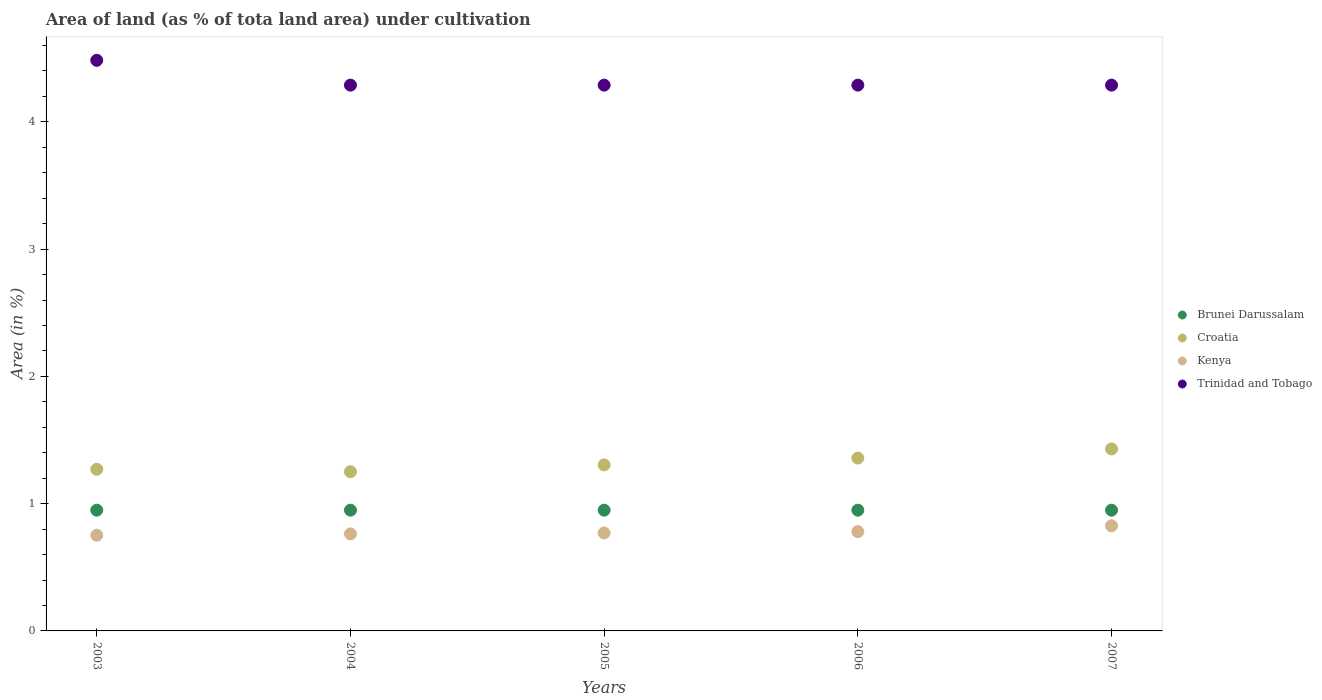How many different coloured dotlines are there?
Make the answer very short. 4. What is the percentage of land under cultivation in Trinidad and Tobago in 2004?
Provide a short and direct response. 4.29. Across all years, what is the maximum percentage of land under cultivation in Brunei Darussalam?
Make the answer very short. 0.95. Across all years, what is the minimum percentage of land under cultivation in Brunei Darussalam?
Your answer should be compact. 0.95. In which year was the percentage of land under cultivation in Kenya minimum?
Give a very brief answer. 2003. What is the total percentage of land under cultivation in Brunei Darussalam in the graph?
Give a very brief answer. 4.74. What is the difference between the percentage of land under cultivation in Trinidad and Tobago in 2005 and that in 2007?
Keep it short and to the point. 0. What is the difference between the percentage of land under cultivation in Trinidad and Tobago in 2004 and the percentage of land under cultivation in Brunei Darussalam in 2003?
Give a very brief answer. 3.34. What is the average percentage of land under cultivation in Croatia per year?
Provide a short and direct response. 1.32. In the year 2004, what is the difference between the percentage of land under cultivation in Kenya and percentage of land under cultivation in Croatia?
Make the answer very short. -0.49. What is the ratio of the percentage of land under cultivation in Kenya in 2005 to that in 2006?
Make the answer very short. 0.99. Is the difference between the percentage of land under cultivation in Kenya in 2005 and 2006 greater than the difference between the percentage of land under cultivation in Croatia in 2005 and 2006?
Ensure brevity in your answer.  Yes. What is the difference between the highest and the second highest percentage of land under cultivation in Croatia?
Your response must be concise. 0.07. Is it the case that in every year, the sum of the percentage of land under cultivation in Brunei Darussalam and percentage of land under cultivation in Croatia  is greater than the percentage of land under cultivation in Kenya?
Make the answer very short. Yes. Is the percentage of land under cultivation in Kenya strictly greater than the percentage of land under cultivation in Brunei Darussalam over the years?
Your answer should be compact. No. How many dotlines are there?
Provide a short and direct response. 4. What is the difference between two consecutive major ticks on the Y-axis?
Ensure brevity in your answer.  1. Are the values on the major ticks of Y-axis written in scientific E-notation?
Make the answer very short. No. Where does the legend appear in the graph?
Your response must be concise. Center right. How are the legend labels stacked?
Give a very brief answer. Vertical. What is the title of the graph?
Give a very brief answer. Area of land (as % of tota land area) under cultivation. What is the label or title of the X-axis?
Provide a short and direct response. Years. What is the label or title of the Y-axis?
Your answer should be compact. Area (in %). What is the Area (in %) in Brunei Darussalam in 2003?
Your answer should be very brief. 0.95. What is the Area (in %) in Croatia in 2003?
Keep it short and to the point. 1.27. What is the Area (in %) in Kenya in 2003?
Keep it short and to the point. 0.75. What is the Area (in %) in Trinidad and Tobago in 2003?
Offer a terse response. 4.48. What is the Area (in %) in Brunei Darussalam in 2004?
Offer a very short reply. 0.95. What is the Area (in %) in Croatia in 2004?
Keep it short and to the point. 1.25. What is the Area (in %) in Kenya in 2004?
Your response must be concise. 0.76. What is the Area (in %) in Trinidad and Tobago in 2004?
Offer a very short reply. 4.29. What is the Area (in %) in Brunei Darussalam in 2005?
Keep it short and to the point. 0.95. What is the Area (in %) in Croatia in 2005?
Your answer should be compact. 1.3. What is the Area (in %) in Kenya in 2005?
Provide a short and direct response. 0.77. What is the Area (in %) in Trinidad and Tobago in 2005?
Give a very brief answer. 4.29. What is the Area (in %) in Brunei Darussalam in 2006?
Your answer should be compact. 0.95. What is the Area (in %) in Croatia in 2006?
Ensure brevity in your answer.  1.36. What is the Area (in %) of Kenya in 2006?
Give a very brief answer. 0.78. What is the Area (in %) of Trinidad and Tobago in 2006?
Your answer should be very brief. 4.29. What is the Area (in %) of Brunei Darussalam in 2007?
Make the answer very short. 0.95. What is the Area (in %) in Croatia in 2007?
Ensure brevity in your answer.  1.43. What is the Area (in %) of Kenya in 2007?
Your answer should be very brief. 0.83. What is the Area (in %) in Trinidad and Tobago in 2007?
Your answer should be compact. 4.29. Across all years, what is the maximum Area (in %) in Brunei Darussalam?
Keep it short and to the point. 0.95. Across all years, what is the maximum Area (in %) of Croatia?
Give a very brief answer. 1.43. Across all years, what is the maximum Area (in %) in Kenya?
Provide a succinct answer. 0.83. Across all years, what is the maximum Area (in %) of Trinidad and Tobago?
Provide a succinct answer. 4.48. Across all years, what is the minimum Area (in %) of Brunei Darussalam?
Offer a terse response. 0.95. Across all years, what is the minimum Area (in %) in Croatia?
Provide a short and direct response. 1.25. Across all years, what is the minimum Area (in %) in Kenya?
Make the answer very short. 0.75. Across all years, what is the minimum Area (in %) in Trinidad and Tobago?
Keep it short and to the point. 4.29. What is the total Area (in %) of Brunei Darussalam in the graph?
Provide a short and direct response. 4.74. What is the total Area (in %) in Croatia in the graph?
Give a very brief answer. 6.61. What is the total Area (in %) in Kenya in the graph?
Your answer should be very brief. 3.89. What is the total Area (in %) in Trinidad and Tobago in the graph?
Make the answer very short. 21.64. What is the difference between the Area (in %) in Croatia in 2003 and that in 2004?
Offer a very short reply. 0.02. What is the difference between the Area (in %) of Kenya in 2003 and that in 2004?
Keep it short and to the point. -0.01. What is the difference between the Area (in %) in Trinidad and Tobago in 2003 and that in 2004?
Provide a short and direct response. 0.19. What is the difference between the Area (in %) of Croatia in 2003 and that in 2005?
Provide a succinct answer. -0.03. What is the difference between the Area (in %) in Kenya in 2003 and that in 2005?
Give a very brief answer. -0.02. What is the difference between the Area (in %) of Trinidad and Tobago in 2003 and that in 2005?
Your answer should be compact. 0.19. What is the difference between the Area (in %) of Croatia in 2003 and that in 2006?
Provide a succinct answer. -0.09. What is the difference between the Area (in %) of Kenya in 2003 and that in 2006?
Provide a short and direct response. -0.03. What is the difference between the Area (in %) of Trinidad and Tobago in 2003 and that in 2006?
Make the answer very short. 0.19. What is the difference between the Area (in %) in Croatia in 2003 and that in 2007?
Give a very brief answer. -0.16. What is the difference between the Area (in %) of Kenya in 2003 and that in 2007?
Your answer should be compact. -0.07. What is the difference between the Area (in %) of Trinidad and Tobago in 2003 and that in 2007?
Your answer should be very brief. 0.19. What is the difference between the Area (in %) of Brunei Darussalam in 2004 and that in 2005?
Provide a short and direct response. 0. What is the difference between the Area (in %) in Croatia in 2004 and that in 2005?
Your answer should be very brief. -0.05. What is the difference between the Area (in %) in Kenya in 2004 and that in 2005?
Ensure brevity in your answer.  -0.01. What is the difference between the Area (in %) of Croatia in 2004 and that in 2006?
Ensure brevity in your answer.  -0.11. What is the difference between the Area (in %) of Kenya in 2004 and that in 2006?
Your response must be concise. -0.02. What is the difference between the Area (in %) in Croatia in 2004 and that in 2007?
Offer a very short reply. -0.18. What is the difference between the Area (in %) in Kenya in 2004 and that in 2007?
Offer a terse response. -0.06. What is the difference between the Area (in %) of Croatia in 2005 and that in 2006?
Provide a short and direct response. -0.05. What is the difference between the Area (in %) in Kenya in 2005 and that in 2006?
Your answer should be compact. -0.01. What is the difference between the Area (in %) in Brunei Darussalam in 2005 and that in 2007?
Your response must be concise. 0. What is the difference between the Area (in %) in Croatia in 2005 and that in 2007?
Provide a succinct answer. -0.13. What is the difference between the Area (in %) of Kenya in 2005 and that in 2007?
Offer a terse response. -0.06. What is the difference between the Area (in %) of Brunei Darussalam in 2006 and that in 2007?
Your answer should be compact. 0. What is the difference between the Area (in %) in Croatia in 2006 and that in 2007?
Keep it short and to the point. -0.07. What is the difference between the Area (in %) of Kenya in 2006 and that in 2007?
Your answer should be compact. -0.05. What is the difference between the Area (in %) of Trinidad and Tobago in 2006 and that in 2007?
Your answer should be compact. 0. What is the difference between the Area (in %) in Brunei Darussalam in 2003 and the Area (in %) in Croatia in 2004?
Offer a terse response. -0.3. What is the difference between the Area (in %) of Brunei Darussalam in 2003 and the Area (in %) of Kenya in 2004?
Provide a succinct answer. 0.19. What is the difference between the Area (in %) in Brunei Darussalam in 2003 and the Area (in %) in Trinidad and Tobago in 2004?
Keep it short and to the point. -3.34. What is the difference between the Area (in %) in Croatia in 2003 and the Area (in %) in Kenya in 2004?
Your answer should be compact. 0.51. What is the difference between the Area (in %) of Croatia in 2003 and the Area (in %) of Trinidad and Tobago in 2004?
Keep it short and to the point. -3.02. What is the difference between the Area (in %) of Kenya in 2003 and the Area (in %) of Trinidad and Tobago in 2004?
Ensure brevity in your answer.  -3.54. What is the difference between the Area (in %) in Brunei Darussalam in 2003 and the Area (in %) in Croatia in 2005?
Your response must be concise. -0.36. What is the difference between the Area (in %) of Brunei Darussalam in 2003 and the Area (in %) of Kenya in 2005?
Your answer should be compact. 0.18. What is the difference between the Area (in %) in Brunei Darussalam in 2003 and the Area (in %) in Trinidad and Tobago in 2005?
Ensure brevity in your answer.  -3.34. What is the difference between the Area (in %) of Croatia in 2003 and the Area (in %) of Kenya in 2005?
Provide a succinct answer. 0.5. What is the difference between the Area (in %) of Croatia in 2003 and the Area (in %) of Trinidad and Tobago in 2005?
Make the answer very short. -3.02. What is the difference between the Area (in %) in Kenya in 2003 and the Area (in %) in Trinidad and Tobago in 2005?
Your answer should be very brief. -3.54. What is the difference between the Area (in %) of Brunei Darussalam in 2003 and the Area (in %) of Croatia in 2006?
Provide a succinct answer. -0.41. What is the difference between the Area (in %) in Brunei Darussalam in 2003 and the Area (in %) in Kenya in 2006?
Keep it short and to the point. 0.17. What is the difference between the Area (in %) of Brunei Darussalam in 2003 and the Area (in %) of Trinidad and Tobago in 2006?
Keep it short and to the point. -3.34. What is the difference between the Area (in %) in Croatia in 2003 and the Area (in %) in Kenya in 2006?
Your answer should be compact. 0.49. What is the difference between the Area (in %) in Croatia in 2003 and the Area (in %) in Trinidad and Tobago in 2006?
Make the answer very short. -3.02. What is the difference between the Area (in %) of Kenya in 2003 and the Area (in %) of Trinidad and Tobago in 2006?
Ensure brevity in your answer.  -3.54. What is the difference between the Area (in %) of Brunei Darussalam in 2003 and the Area (in %) of Croatia in 2007?
Provide a succinct answer. -0.48. What is the difference between the Area (in %) in Brunei Darussalam in 2003 and the Area (in %) in Kenya in 2007?
Provide a succinct answer. 0.12. What is the difference between the Area (in %) in Brunei Darussalam in 2003 and the Area (in %) in Trinidad and Tobago in 2007?
Offer a terse response. -3.34. What is the difference between the Area (in %) of Croatia in 2003 and the Area (in %) of Kenya in 2007?
Give a very brief answer. 0.44. What is the difference between the Area (in %) in Croatia in 2003 and the Area (in %) in Trinidad and Tobago in 2007?
Your answer should be very brief. -3.02. What is the difference between the Area (in %) of Kenya in 2003 and the Area (in %) of Trinidad and Tobago in 2007?
Offer a very short reply. -3.54. What is the difference between the Area (in %) of Brunei Darussalam in 2004 and the Area (in %) of Croatia in 2005?
Keep it short and to the point. -0.36. What is the difference between the Area (in %) of Brunei Darussalam in 2004 and the Area (in %) of Kenya in 2005?
Provide a short and direct response. 0.18. What is the difference between the Area (in %) of Brunei Darussalam in 2004 and the Area (in %) of Trinidad and Tobago in 2005?
Provide a short and direct response. -3.34. What is the difference between the Area (in %) in Croatia in 2004 and the Area (in %) in Kenya in 2005?
Make the answer very short. 0.48. What is the difference between the Area (in %) of Croatia in 2004 and the Area (in %) of Trinidad and Tobago in 2005?
Keep it short and to the point. -3.04. What is the difference between the Area (in %) of Kenya in 2004 and the Area (in %) of Trinidad and Tobago in 2005?
Keep it short and to the point. -3.53. What is the difference between the Area (in %) in Brunei Darussalam in 2004 and the Area (in %) in Croatia in 2006?
Your answer should be compact. -0.41. What is the difference between the Area (in %) in Brunei Darussalam in 2004 and the Area (in %) in Kenya in 2006?
Your answer should be very brief. 0.17. What is the difference between the Area (in %) of Brunei Darussalam in 2004 and the Area (in %) of Trinidad and Tobago in 2006?
Offer a terse response. -3.34. What is the difference between the Area (in %) in Croatia in 2004 and the Area (in %) in Kenya in 2006?
Your response must be concise. 0.47. What is the difference between the Area (in %) of Croatia in 2004 and the Area (in %) of Trinidad and Tobago in 2006?
Provide a succinct answer. -3.04. What is the difference between the Area (in %) of Kenya in 2004 and the Area (in %) of Trinidad and Tobago in 2006?
Keep it short and to the point. -3.53. What is the difference between the Area (in %) in Brunei Darussalam in 2004 and the Area (in %) in Croatia in 2007?
Provide a succinct answer. -0.48. What is the difference between the Area (in %) in Brunei Darussalam in 2004 and the Area (in %) in Kenya in 2007?
Your response must be concise. 0.12. What is the difference between the Area (in %) in Brunei Darussalam in 2004 and the Area (in %) in Trinidad and Tobago in 2007?
Your answer should be very brief. -3.34. What is the difference between the Area (in %) of Croatia in 2004 and the Area (in %) of Kenya in 2007?
Ensure brevity in your answer.  0.43. What is the difference between the Area (in %) of Croatia in 2004 and the Area (in %) of Trinidad and Tobago in 2007?
Your answer should be very brief. -3.04. What is the difference between the Area (in %) of Kenya in 2004 and the Area (in %) of Trinidad and Tobago in 2007?
Offer a very short reply. -3.53. What is the difference between the Area (in %) in Brunei Darussalam in 2005 and the Area (in %) in Croatia in 2006?
Offer a very short reply. -0.41. What is the difference between the Area (in %) in Brunei Darussalam in 2005 and the Area (in %) in Kenya in 2006?
Ensure brevity in your answer.  0.17. What is the difference between the Area (in %) in Brunei Darussalam in 2005 and the Area (in %) in Trinidad and Tobago in 2006?
Offer a terse response. -3.34. What is the difference between the Area (in %) in Croatia in 2005 and the Area (in %) in Kenya in 2006?
Provide a succinct answer. 0.52. What is the difference between the Area (in %) of Croatia in 2005 and the Area (in %) of Trinidad and Tobago in 2006?
Your answer should be very brief. -2.98. What is the difference between the Area (in %) of Kenya in 2005 and the Area (in %) of Trinidad and Tobago in 2006?
Your response must be concise. -3.52. What is the difference between the Area (in %) in Brunei Darussalam in 2005 and the Area (in %) in Croatia in 2007?
Your answer should be compact. -0.48. What is the difference between the Area (in %) of Brunei Darussalam in 2005 and the Area (in %) of Kenya in 2007?
Make the answer very short. 0.12. What is the difference between the Area (in %) in Brunei Darussalam in 2005 and the Area (in %) in Trinidad and Tobago in 2007?
Provide a succinct answer. -3.34. What is the difference between the Area (in %) in Croatia in 2005 and the Area (in %) in Kenya in 2007?
Offer a terse response. 0.48. What is the difference between the Area (in %) of Croatia in 2005 and the Area (in %) of Trinidad and Tobago in 2007?
Provide a succinct answer. -2.98. What is the difference between the Area (in %) in Kenya in 2005 and the Area (in %) in Trinidad and Tobago in 2007?
Your answer should be very brief. -3.52. What is the difference between the Area (in %) of Brunei Darussalam in 2006 and the Area (in %) of Croatia in 2007?
Your answer should be compact. -0.48. What is the difference between the Area (in %) in Brunei Darussalam in 2006 and the Area (in %) in Kenya in 2007?
Provide a succinct answer. 0.12. What is the difference between the Area (in %) of Brunei Darussalam in 2006 and the Area (in %) of Trinidad and Tobago in 2007?
Give a very brief answer. -3.34. What is the difference between the Area (in %) of Croatia in 2006 and the Area (in %) of Kenya in 2007?
Your response must be concise. 0.53. What is the difference between the Area (in %) of Croatia in 2006 and the Area (in %) of Trinidad and Tobago in 2007?
Provide a succinct answer. -2.93. What is the difference between the Area (in %) of Kenya in 2006 and the Area (in %) of Trinidad and Tobago in 2007?
Your response must be concise. -3.51. What is the average Area (in %) of Brunei Darussalam per year?
Provide a short and direct response. 0.95. What is the average Area (in %) in Croatia per year?
Offer a terse response. 1.32. What is the average Area (in %) in Kenya per year?
Keep it short and to the point. 0.78. What is the average Area (in %) in Trinidad and Tobago per year?
Ensure brevity in your answer.  4.33. In the year 2003, what is the difference between the Area (in %) in Brunei Darussalam and Area (in %) in Croatia?
Provide a succinct answer. -0.32. In the year 2003, what is the difference between the Area (in %) in Brunei Darussalam and Area (in %) in Kenya?
Provide a short and direct response. 0.2. In the year 2003, what is the difference between the Area (in %) in Brunei Darussalam and Area (in %) in Trinidad and Tobago?
Offer a terse response. -3.53. In the year 2003, what is the difference between the Area (in %) in Croatia and Area (in %) in Kenya?
Ensure brevity in your answer.  0.52. In the year 2003, what is the difference between the Area (in %) in Croatia and Area (in %) in Trinidad and Tobago?
Make the answer very short. -3.21. In the year 2003, what is the difference between the Area (in %) of Kenya and Area (in %) of Trinidad and Tobago?
Keep it short and to the point. -3.73. In the year 2004, what is the difference between the Area (in %) in Brunei Darussalam and Area (in %) in Croatia?
Ensure brevity in your answer.  -0.3. In the year 2004, what is the difference between the Area (in %) of Brunei Darussalam and Area (in %) of Kenya?
Provide a succinct answer. 0.19. In the year 2004, what is the difference between the Area (in %) in Brunei Darussalam and Area (in %) in Trinidad and Tobago?
Offer a terse response. -3.34. In the year 2004, what is the difference between the Area (in %) of Croatia and Area (in %) of Kenya?
Provide a short and direct response. 0.49. In the year 2004, what is the difference between the Area (in %) in Croatia and Area (in %) in Trinidad and Tobago?
Provide a succinct answer. -3.04. In the year 2004, what is the difference between the Area (in %) in Kenya and Area (in %) in Trinidad and Tobago?
Your answer should be very brief. -3.53. In the year 2005, what is the difference between the Area (in %) in Brunei Darussalam and Area (in %) in Croatia?
Your response must be concise. -0.36. In the year 2005, what is the difference between the Area (in %) in Brunei Darussalam and Area (in %) in Kenya?
Ensure brevity in your answer.  0.18. In the year 2005, what is the difference between the Area (in %) in Brunei Darussalam and Area (in %) in Trinidad and Tobago?
Give a very brief answer. -3.34. In the year 2005, what is the difference between the Area (in %) of Croatia and Area (in %) of Kenya?
Offer a terse response. 0.53. In the year 2005, what is the difference between the Area (in %) of Croatia and Area (in %) of Trinidad and Tobago?
Your response must be concise. -2.98. In the year 2005, what is the difference between the Area (in %) of Kenya and Area (in %) of Trinidad and Tobago?
Give a very brief answer. -3.52. In the year 2006, what is the difference between the Area (in %) of Brunei Darussalam and Area (in %) of Croatia?
Your answer should be very brief. -0.41. In the year 2006, what is the difference between the Area (in %) in Brunei Darussalam and Area (in %) in Kenya?
Give a very brief answer. 0.17. In the year 2006, what is the difference between the Area (in %) of Brunei Darussalam and Area (in %) of Trinidad and Tobago?
Give a very brief answer. -3.34. In the year 2006, what is the difference between the Area (in %) in Croatia and Area (in %) in Kenya?
Your response must be concise. 0.58. In the year 2006, what is the difference between the Area (in %) of Croatia and Area (in %) of Trinidad and Tobago?
Your answer should be compact. -2.93. In the year 2006, what is the difference between the Area (in %) of Kenya and Area (in %) of Trinidad and Tobago?
Offer a terse response. -3.51. In the year 2007, what is the difference between the Area (in %) in Brunei Darussalam and Area (in %) in Croatia?
Your answer should be compact. -0.48. In the year 2007, what is the difference between the Area (in %) in Brunei Darussalam and Area (in %) in Kenya?
Provide a short and direct response. 0.12. In the year 2007, what is the difference between the Area (in %) of Brunei Darussalam and Area (in %) of Trinidad and Tobago?
Your answer should be compact. -3.34. In the year 2007, what is the difference between the Area (in %) in Croatia and Area (in %) in Kenya?
Keep it short and to the point. 0.6. In the year 2007, what is the difference between the Area (in %) of Croatia and Area (in %) of Trinidad and Tobago?
Your answer should be very brief. -2.86. In the year 2007, what is the difference between the Area (in %) of Kenya and Area (in %) of Trinidad and Tobago?
Provide a succinct answer. -3.46. What is the ratio of the Area (in %) of Brunei Darussalam in 2003 to that in 2004?
Offer a very short reply. 1. What is the ratio of the Area (in %) in Croatia in 2003 to that in 2004?
Your answer should be very brief. 1.02. What is the ratio of the Area (in %) in Kenya in 2003 to that in 2004?
Keep it short and to the point. 0.99. What is the ratio of the Area (in %) in Trinidad and Tobago in 2003 to that in 2004?
Ensure brevity in your answer.  1.05. What is the ratio of the Area (in %) in Croatia in 2003 to that in 2005?
Your response must be concise. 0.97. What is the ratio of the Area (in %) of Kenya in 2003 to that in 2005?
Provide a succinct answer. 0.98. What is the ratio of the Area (in %) of Trinidad and Tobago in 2003 to that in 2005?
Your response must be concise. 1.05. What is the ratio of the Area (in %) of Brunei Darussalam in 2003 to that in 2006?
Provide a succinct answer. 1. What is the ratio of the Area (in %) in Croatia in 2003 to that in 2006?
Ensure brevity in your answer.  0.94. What is the ratio of the Area (in %) in Kenya in 2003 to that in 2006?
Make the answer very short. 0.96. What is the ratio of the Area (in %) in Trinidad and Tobago in 2003 to that in 2006?
Keep it short and to the point. 1.05. What is the ratio of the Area (in %) of Croatia in 2003 to that in 2007?
Your answer should be very brief. 0.89. What is the ratio of the Area (in %) in Kenya in 2003 to that in 2007?
Give a very brief answer. 0.91. What is the ratio of the Area (in %) of Trinidad and Tobago in 2003 to that in 2007?
Make the answer very short. 1.05. What is the ratio of the Area (in %) in Brunei Darussalam in 2004 to that in 2005?
Your answer should be compact. 1. What is the ratio of the Area (in %) of Croatia in 2004 to that in 2005?
Provide a short and direct response. 0.96. What is the ratio of the Area (in %) of Kenya in 2004 to that in 2005?
Your response must be concise. 0.99. What is the ratio of the Area (in %) of Brunei Darussalam in 2004 to that in 2006?
Make the answer very short. 1. What is the ratio of the Area (in %) in Croatia in 2004 to that in 2006?
Provide a succinct answer. 0.92. What is the ratio of the Area (in %) in Kenya in 2004 to that in 2006?
Your response must be concise. 0.98. What is the ratio of the Area (in %) in Trinidad and Tobago in 2004 to that in 2006?
Provide a short and direct response. 1. What is the ratio of the Area (in %) of Croatia in 2004 to that in 2007?
Keep it short and to the point. 0.88. What is the ratio of the Area (in %) of Kenya in 2004 to that in 2007?
Ensure brevity in your answer.  0.92. What is the ratio of the Area (in %) of Brunei Darussalam in 2005 to that in 2006?
Ensure brevity in your answer.  1. What is the ratio of the Area (in %) in Croatia in 2005 to that in 2006?
Ensure brevity in your answer.  0.96. What is the ratio of the Area (in %) of Kenya in 2005 to that in 2006?
Offer a terse response. 0.99. What is the ratio of the Area (in %) of Croatia in 2005 to that in 2007?
Give a very brief answer. 0.91. What is the ratio of the Area (in %) in Kenya in 2005 to that in 2007?
Your answer should be very brief. 0.93. What is the ratio of the Area (in %) of Croatia in 2006 to that in 2007?
Keep it short and to the point. 0.95. What is the ratio of the Area (in %) of Kenya in 2006 to that in 2007?
Keep it short and to the point. 0.94. What is the difference between the highest and the second highest Area (in %) of Croatia?
Your answer should be compact. 0.07. What is the difference between the highest and the second highest Area (in %) in Kenya?
Your answer should be very brief. 0.05. What is the difference between the highest and the second highest Area (in %) in Trinidad and Tobago?
Your answer should be very brief. 0.19. What is the difference between the highest and the lowest Area (in %) in Brunei Darussalam?
Provide a succinct answer. 0. What is the difference between the highest and the lowest Area (in %) in Croatia?
Ensure brevity in your answer.  0.18. What is the difference between the highest and the lowest Area (in %) in Kenya?
Provide a succinct answer. 0.07. What is the difference between the highest and the lowest Area (in %) in Trinidad and Tobago?
Keep it short and to the point. 0.19. 